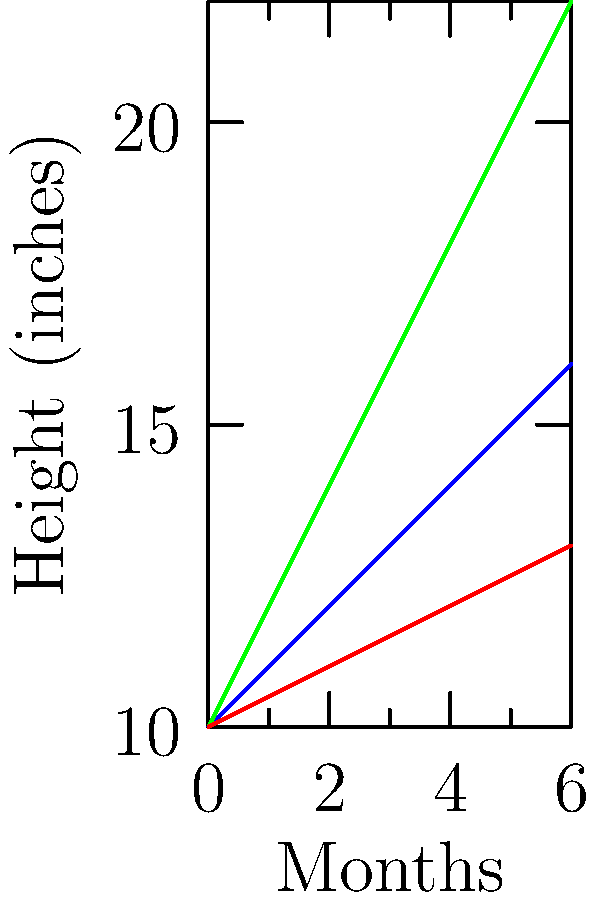Based on the growth chart of three low-maintenance indoor plants over six months, which plant shows the fastest growth rate and would be the best choice for quickly adding greenery to a room? To determine the fastest growing plant, we need to compare the growth rates of each plant over the six-month period:

1. Snake Plant:
   Initial height: 10 inches
   Final height: 16 inches
   Total growth: 16 - 10 = 6 inches

2. Pothos:
   Initial height: 10 inches
   Final height: 22 inches
   Total growth: 22 - 10 = 12 inches

3. ZZ Plant:
   Initial height: 10 inches
   Final height: 13 inches
   Total growth: 13 - 10 = 3 inches

Calculating growth rate:
Growth rate = Total growth / Time period

Snake Plant: 6 inches / 6 months = 1 inch/month
Pothos: 12 inches / 6 months = 2 inches/month
ZZ Plant: 3 inches / 6 months = 0.5 inches/month

The Pothos has the highest growth rate at 2 inches per month, making it the fastest growing plant and the best choice for quickly adding greenery to a room.
Answer: Pothos 